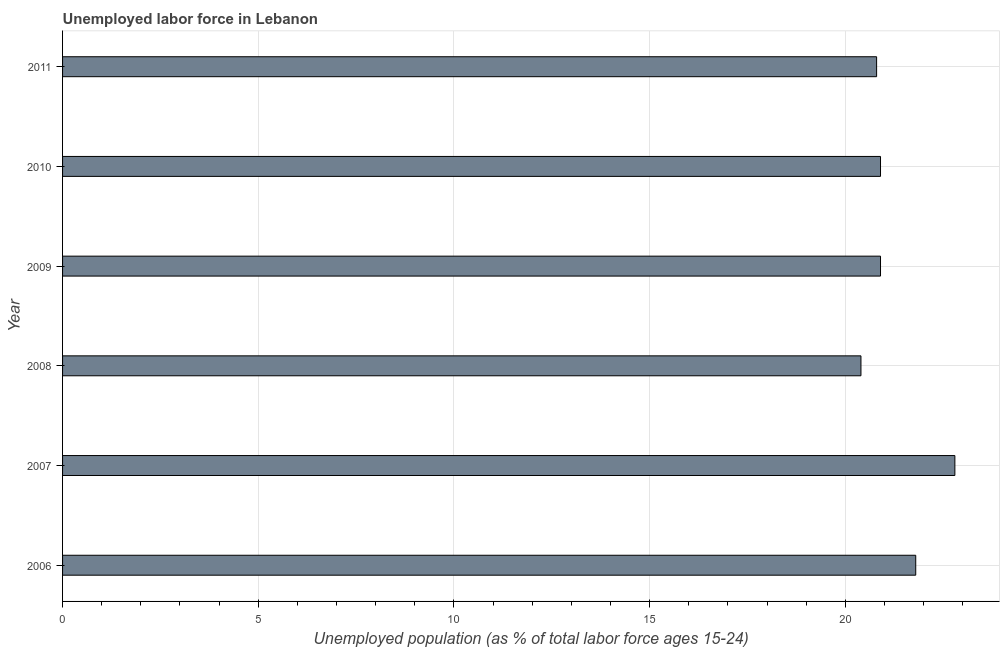Does the graph contain any zero values?
Give a very brief answer. No. What is the title of the graph?
Your response must be concise. Unemployed labor force in Lebanon. What is the label or title of the X-axis?
Your answer should be compact. Unemployed population (as % of total labor force ages 15-24). What is the total unemployed youth population in 2011?
Your response must be concise. 20.8. Across all years, what is the maximum total unemployed youth population?
Provide a short and direct response. 22.8. Across all years, what is the minimum total unemployed youth population?
Offer a very short reply. 20.4. In which year was the total unemployed youth population maximum?
Ensure brevity in your answer.  2007. What is the sum of the total unemployed youth population?
Your response must be concise. 127.6. What is the difference between the total unemployed youth population in 2006 and 2008?
Ensure brevity in your answer.  1.4. What is the average total unemployed youth population per year?
Provide a short and direct response. 21.27. What is the median total unemployed youth population?
Ensure brevity in your answer.  20.9. Do a majority of the years between 2006 and 2011 (inclusive) have total unemployed youth population greater than 18 %?
Give a very brief answer. Yes. What is the ratio of the total unemployed youth population in 2006 to that in 2011?
Your response must be concise. 1.05. Is the difference between the total unemployed youth population in 2007 and 2009 greater than the difference between any two years?
Your answer should be compact. No. In how many years, is the total unemployed youth population greater than the average total unemployed youth population taken over all years?
Offer a terse response. 2. How many bars are there?
Give a very brief answer. 6. Are all the bars in the graph horizontal?
Provide a short and direct response. Yes. How many years are there in the graph?
Keep it short and to the point. 6. What is the Unemployed population (as % of total labor force ages 15-24) of 2006?
Make the answer very short. 21.8. What is the Unemployed population (as % of total labor force ages 15-24) in 2007?
Offer a very short reply. 22.8. What is the Unemployed population (as % of total labor force ages 15-24) of 2008?
Your answer should be compact. 20.4. What is the Unemployed population (as % of total labor force ages 15-24) in 2009?
Keep it short and to the point. 20.9. What is the Unemployed population (as % of total labor force ages 15-24) of 2010?
Your answer should be very brief. 20.9. What is the Unemployed population (as % of total labor force ages 15-24) of 2011?
Offer a very short reply. 20.8. What is the difference between the Unemployed population (as % of total labor force ages 15-24) in 2006 and 2007?
Your answer should be compact. -1. What is the difference between the Unemployed population (as % of total labor force ages 15-24) in 2006 and 2008?
Ensure brevity in your answer.  1.4. What is the difference between the Unemployed population (as % of total labor force ages 15-24) in 2007 and 2008?
Make the answer very short. 2.4. What is the difference between the Unemployed population (as % of total labor force ages 15-24) in 2007 and 2009?
Provide a succinct answer. 1.9. What is the difference between the Unemployed population (as % of total labor force ages 15-24) in 2007 and 2011?
Keep it short and to the point. 2. What is the difference between the Unemployed population (as % of total labor force ages 15-24) in 2009 and 2010?
Your response must be concise. 0. What is the difference between the Unemployed population (as % of total labor force ages 15-24) in 2010 and 2011?
Give a very brief answer. 0.1. What is the ratio of the Unemployed population (as % of total labor force ages 15-24) in 2006 to that in 2007?
Keep it short and to the point. 0.96. What is the ratio of the Unemployed population (as % of total labor force ages 15-24) in 2006 to that in 2008?
Offer a terse response. 1.07. What is the ratio of the Unemployed population (as % of total labor force ages 15-24) in 2006 to that in 2009?
Provide a short and direct response. 1.04. What is the ratio of the Unemployed population (as % of total labor force ages 15-24) in 2006 to that in 2010?
Your response must be concise. 1.04. What is the ratio of the Unemployed population (as % of total labor force ages 15-24) in 2006 to that in 2011?
Offer a very short reply. 1.05. What is the ratio of the Unemployed population (as % of total labor force ages 15-24) in 2007 to that in 2008?
Your response must be concise. 1.12. What is the ratio of the Unemployed population (as % of total labor force ages 15-24) in 2007 to that in 2009?
Offer a very short reply. 1.09. What is the ratio of the Unemployed population (as % of total labor force ages 15-24) in 2007 to that in 2010?
Make the answer very short. 1.09. What is the ratio of the Unemployed population (as % of total labor force ages 15-24) in 2007 to that in 2011?
Keep it short and to the point. 1.1. What is the ratio of the Unemployed population (as % of total labor force ages 15-24) in 2008 to that in 2009?
Make the answer very short. 0.98. What is the ratio of the Unemployed population (as % of total labor force ages 15-24) in 2008 to that in 2010?
Make the answer very short. 0.98. What is the ratio of the Unemployed population (as % of total labor force ages 15-24) in 2008 to that in 2011?
Give a very brief answer. 0.98. What is the ratio of the Unemployed population (as % of total labor force ages 15-24) in 2010 to that in 2011?
Give a very brief answer. 1. 